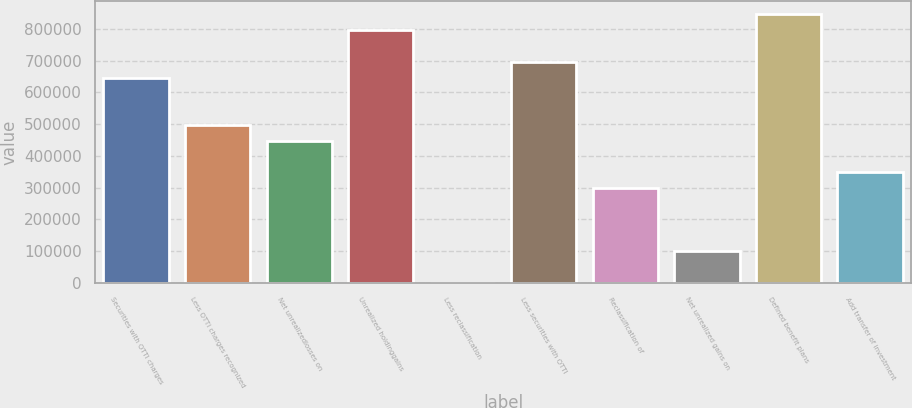<chart> <loc_0><loc_0><loc_500><loc_500><bar_chart><fcel>Securities with OTTI charges<fcel>Less OTTI charges recognized<fcel>Net unrealizedlosses on<fcel>Unrealized holdinggains<fcel>Less reclassification<fcel>Less securities with OTTI<fcel>Reclassification of<fcel>Net unrealized gains on<fcel>Defined benefit plans<fcel>Add transfer of investment<nl><fcel>646400<fcel>497262<fcel>447549<fcel>795539<fcel>134<fcel>696113<fcel>298411<fcel>99559.6<fcel>845252<fcel>348124<nl></chart> 